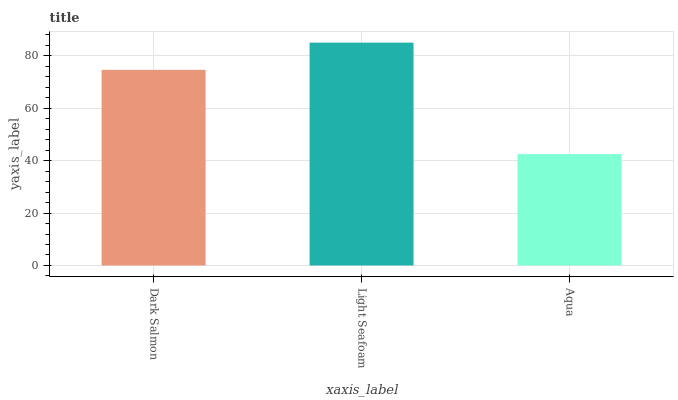Is Light Seafoam the minimum?
Answer yes or no. No. Is Aqua the maximum?
Answer yes or no. No. Is Light Seafoam greater than Aqua?
Answer yes or no. Yes. Is Aqua less than Light Seafoam?
Answer yes or no. Yes. Is Aqua greater than Light Seafoam?
Answer yes or no. No. Is Light Seafoam less than Aqua?
Answer yes or no. No. Is Dark Salmon the high median?
Answer yes or no. Yes. Is Dark Salmon the low median?
Answer yes or no. Yes. Is Light Seafoam the high median?
Answer yes or no. No. Is Light Seafoam the low median?
Answer yes or no. No. 